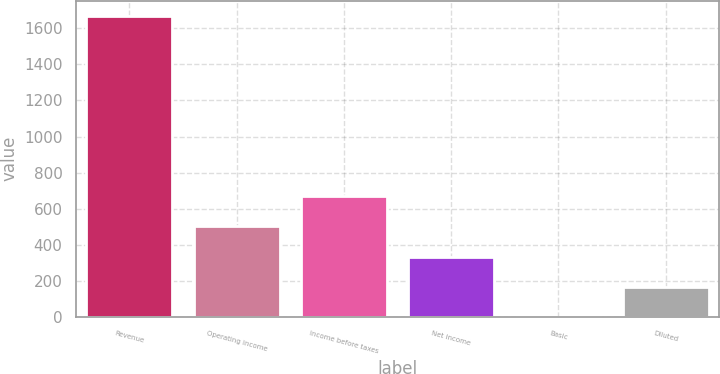<chart> <loc_0><loc_0><loc_500><loc_500><bar_chart><fcel>Revenue<fcel>Operating income<fcel>Income before taxes<fcel>Net income<fcel>Basic<fcel>Diluted<nl><fcel>1670.1<fcel>502.12<fcel>668.98<fcel>335.26<fcel>1.55<fcel>168.41<nl></chart> 